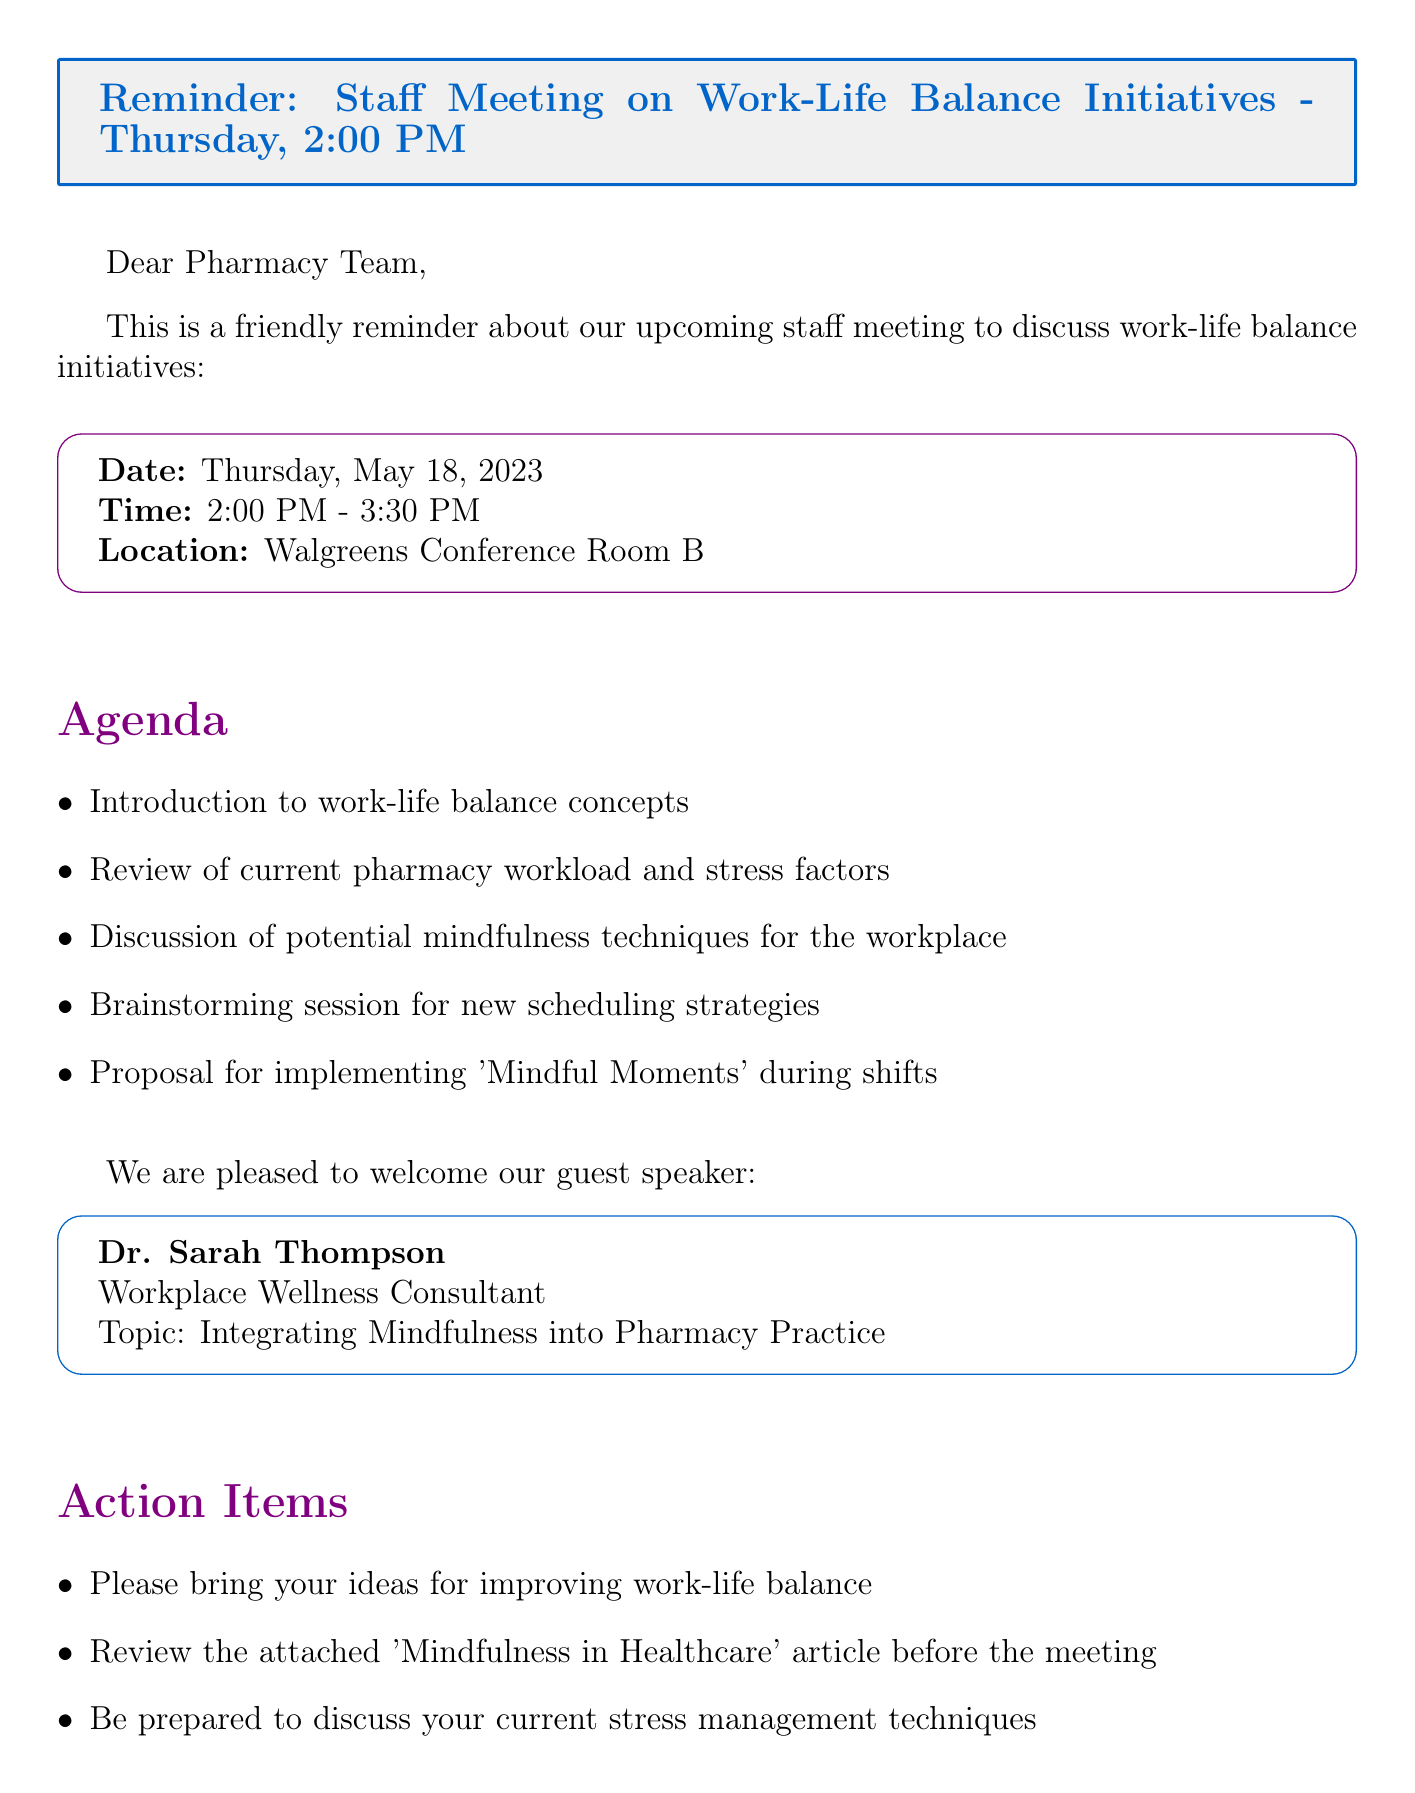What is the date of the staff meeting? The date of the staff meeting is explicitly stated in the meeting details section of the document.
Answer: Thursday, May 18, 2023 What time does the staff meeting start? The starting time of the meeting can be found in the meeting details section.
Answer: 2:00 PM Who is the guest speaker? The name of the guest speaker is provided in a dedicated section about the guest speaker.
Answer: Dr. Sarah Thompson What is Dr. Sarah Thompson's title? Dr. Sarah Thompson's title is mentioned right after her name in the guest speaker section.
Answer: Workplace Wellness Consultant What topic will Dr. Sarah Thompson discuss? The topic of discussion by the guest speaker is listed in the same section.
Answer: Integrating Mindfulness into Pharmacy Practice What should staff bring to the meeting? One of the action items specifically mentions what staff should bring to the meeting.
Answer: Ideas for improving work-life balance How long is the staff meeting scheduled to last? The duration of the meeting is provided alongside the start time in the meeting details.
Answer: 1 hour 30 minutes What is one agenda item related to mindfulness? The agenda items list potential topics of discussion including ones related to mindfulness.
Answer: Discussion of potential mindfulness techniques for the workplace What is the location of the meeting? The location of the staff meeting is provided in the meeting details section.
Answer: Walgreens Conference Room B 